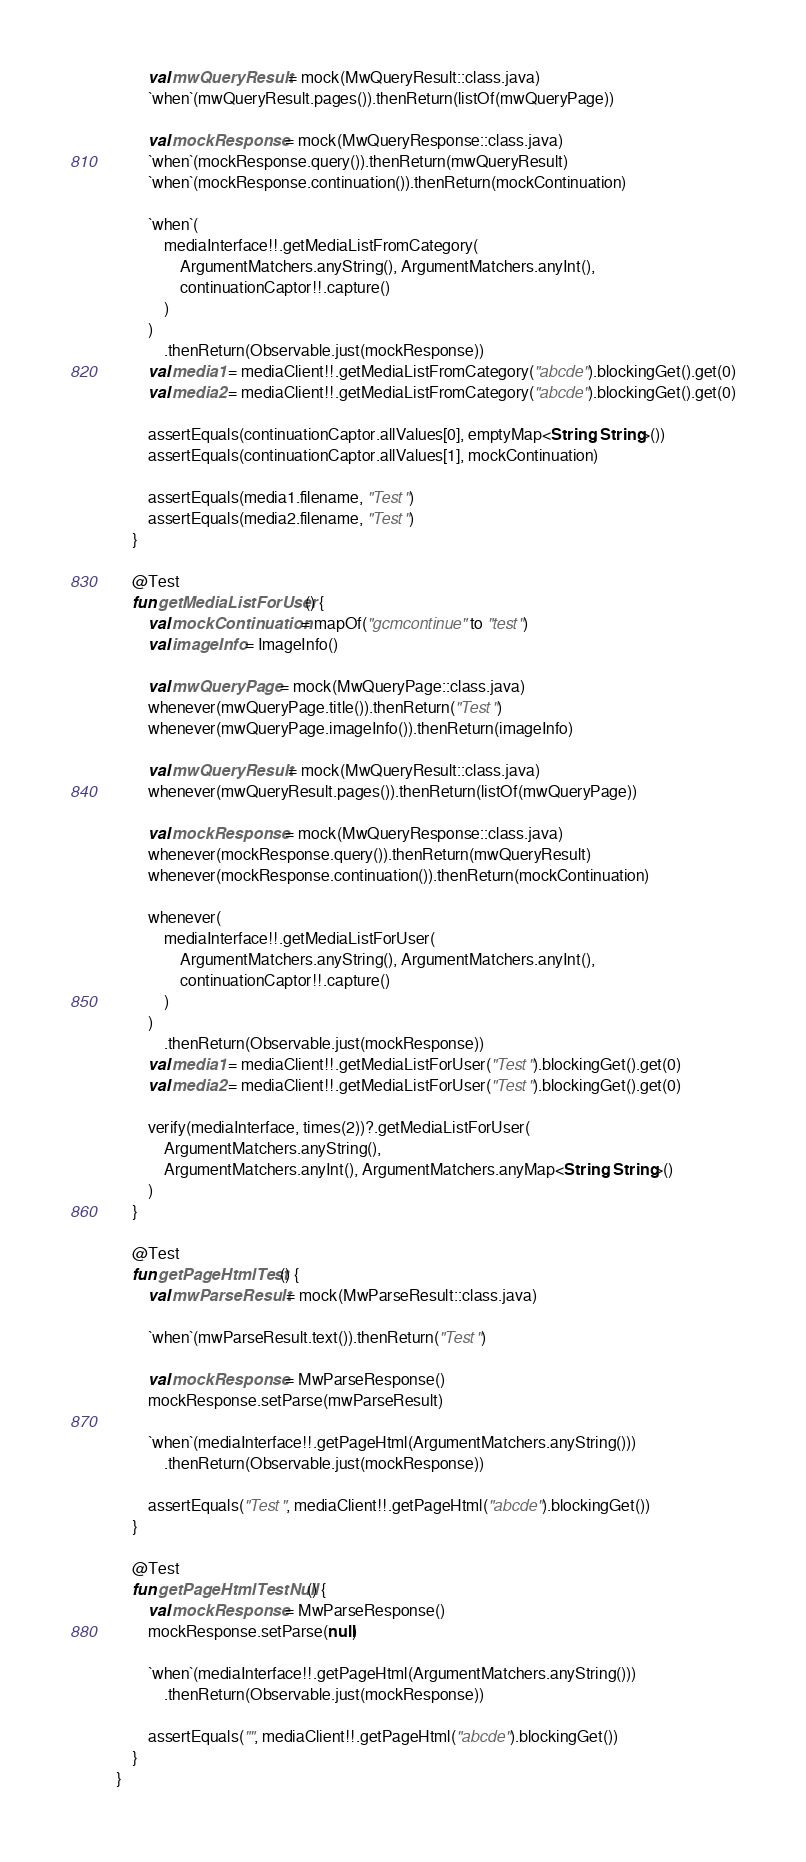<code> <loc_0><loc_0><loc_500><loc_500><_Kotlin_>
        val mwQueryResult = mock(MwQueryResult::class.java)
        `when`(mwQueryResult.pages()).thenReturn(listOf(mwQueryPage))

        val mockResponse = mock(MwQueryResponse::class.java)
        `when`(mockResponse.query()).thenReturn(mwQueryResult)
        `when`(mockResponse.continuation()).thenReturn(mockContinuation)

        `when`(
            mediaInterface!!.getMediaListFromCategory(
                ArgumentMatchers.anyString(), ArgumentMatchers.anyInt(),
                continuationCaptor!!.capture()
            )
        )
            .thenReturn(Observable.just(mockResponse))
        val media1 = mediaClient!!.getMediaListFromCategory("abcde").blockingGet().get(0)
        val media2 = mediaClient!!.getMediaListFromCategory("abcde").blockingGet().get(0)

        assertEquals(continuationCaptor.allValues[0], emptyMap<String, String>())
        assertEquals(continuationCaptor.allValues[1], mockContinuation)

        assertEquals(media1.filename, "Test")
        assertEquals(media2.filename, "Test")
    }

    @Test
    fun getMediaListForUser() {
        val mockContinuation = mapOf("gcmcontinue" to "test")
        val imageInfo = ImageInfo()

        val mwQueryPage = mock(MwQueryPage::class.java)
        whenever(mwQueryPage.title()).thenReturn("Test")
        whenever(mwQueryPage.imageInfo()).thenReturn(imageInfo)

        val mwQueryResult = mock(MwQueryResult::class.java)
        whenever(mwQueryResult.pages()).thenReturn(listOf(mwQueryPage))

        val mockResponse = mock(MwQueryResponse::class.java)
        whenever(mockResponse.query()).thenReturn(mwQueryResult)
        whenever(mockResponse.continuation()).thenReturn(mockContinuation)

        whenever(
            mediaInterface!!.getMediaListForUser(
                ArgumentMatchers.anyString(), ArgumentMatchers.anyInt(),
                continuationCaptor!!.capture()
            )
        )
            .thenReturn(Observable.just(mockResponse))
        val media1 = mediaClient!!.getMediaListForUser("Test").blockingGet().get(0)
        val media2 = mediaClient!!.getMediaListForUser("Test").blockingGet().get(0)

        verify(mediaInterface, times(2))?.getMediaListForUser(
            ArgumentMatchers.anyString(),
            ArgumentMatchers.anyInt(), ArgumentMatchers.anyMap<String, String>()
        )
    }

    @Test
    fun getPageHtmlTest() {
        val mwParseResult = mock(MwParseResult::class.java)

        `when`(mwParseResult.text()).thenReturn("Test")

        val mockResponse = MwParseResponse()
        mockResponse.setParse(mwParseResult)

        `when`(mediaInterface!!.getPageHtml(ArgumentMatchers.anyString()))
            .thenReturn(Observable.just(mockResponse))

        assertEquals("Test", mediaClient!!.getPageHtml("abcde").blockingGet())
    }

    @Test
    fun getPageHtmlTestNull() {
        val mockResponse = MwParseResponse()
        mockResponse.setParse(null)

        `when`(mediaInterface!!.getPageHtml(ArgumentMatchers.anyString()))
            .thenReturn(Observable.just(mockResponse))

        assertEquals("", mediaClient!!.getPageHtml("abcde").blockingGet())
    }
}</code> 